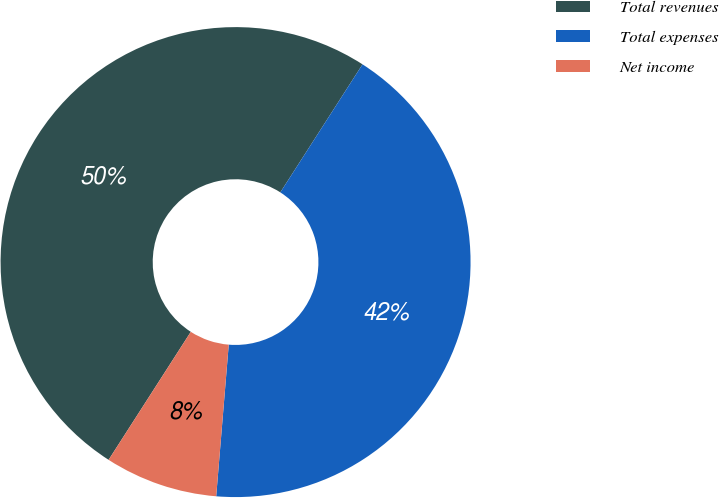Convert chart to OTSL. <chart><loc_0><loc_0><loc_500><loc_500><pie_chart><fcel>Total revenues<fcel>Total expenses<fcel>Net income<nl><fcel>50.0%<fcel>42.23%<fcel>7.77%<nl></chart> 